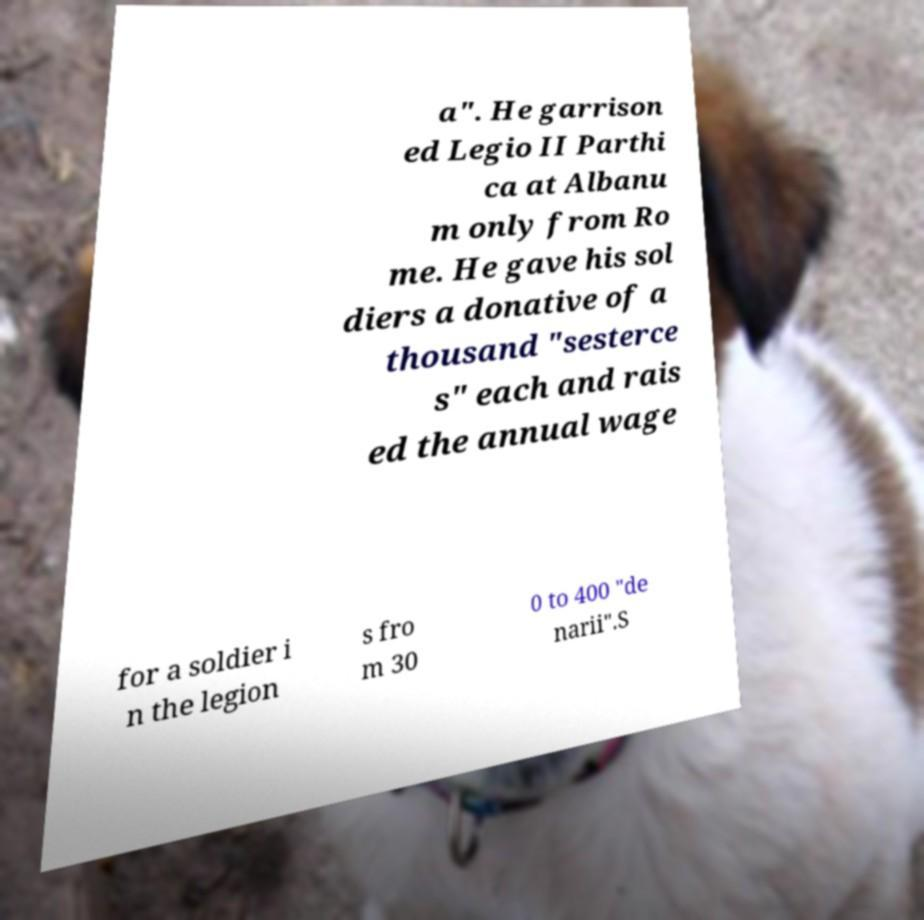Can you accurately transcribe the text from the provided image for me? a". He garrison ed Legio II Parthi ca at Albanu m only from Ro me. He gave his sol diers a donative of a thousand "sesterce s" each and rais ed the annual wage for a soldier i n the legion s fro m 30 0 to 400 "de narii".S 